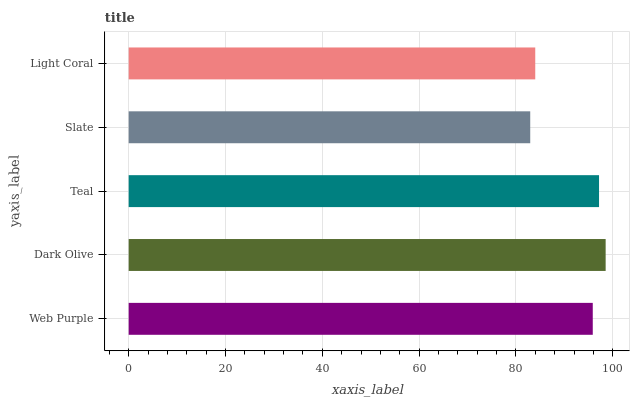Is Slate the minimum?
Answer yes or no. Yes. Is Dark Olive the maximum?
Answer yes or no. Yes. Is Teal the minimum?
Answer yes or no. No. Is Teal the maximum?
Answer yes or no. No. Is Dark Olive greater than Teal?
Answer yes or no. Yes. Is Teal less than Dark Olive?
Answer yes or no. Yes. Is Teal greater than Dark Olive?
Answer yes or no. No. Is Dark Olive less than Teal?
Answer yes or no. No. Is Web Purple the high median?
Answer yes or no. Yes. Is Web Purple the low median?
Answer yes or no. Yes. Is Light Coral the high median?
Answer yes or no. No. Is Light Coral the low median?
Answer yes or no. No. 